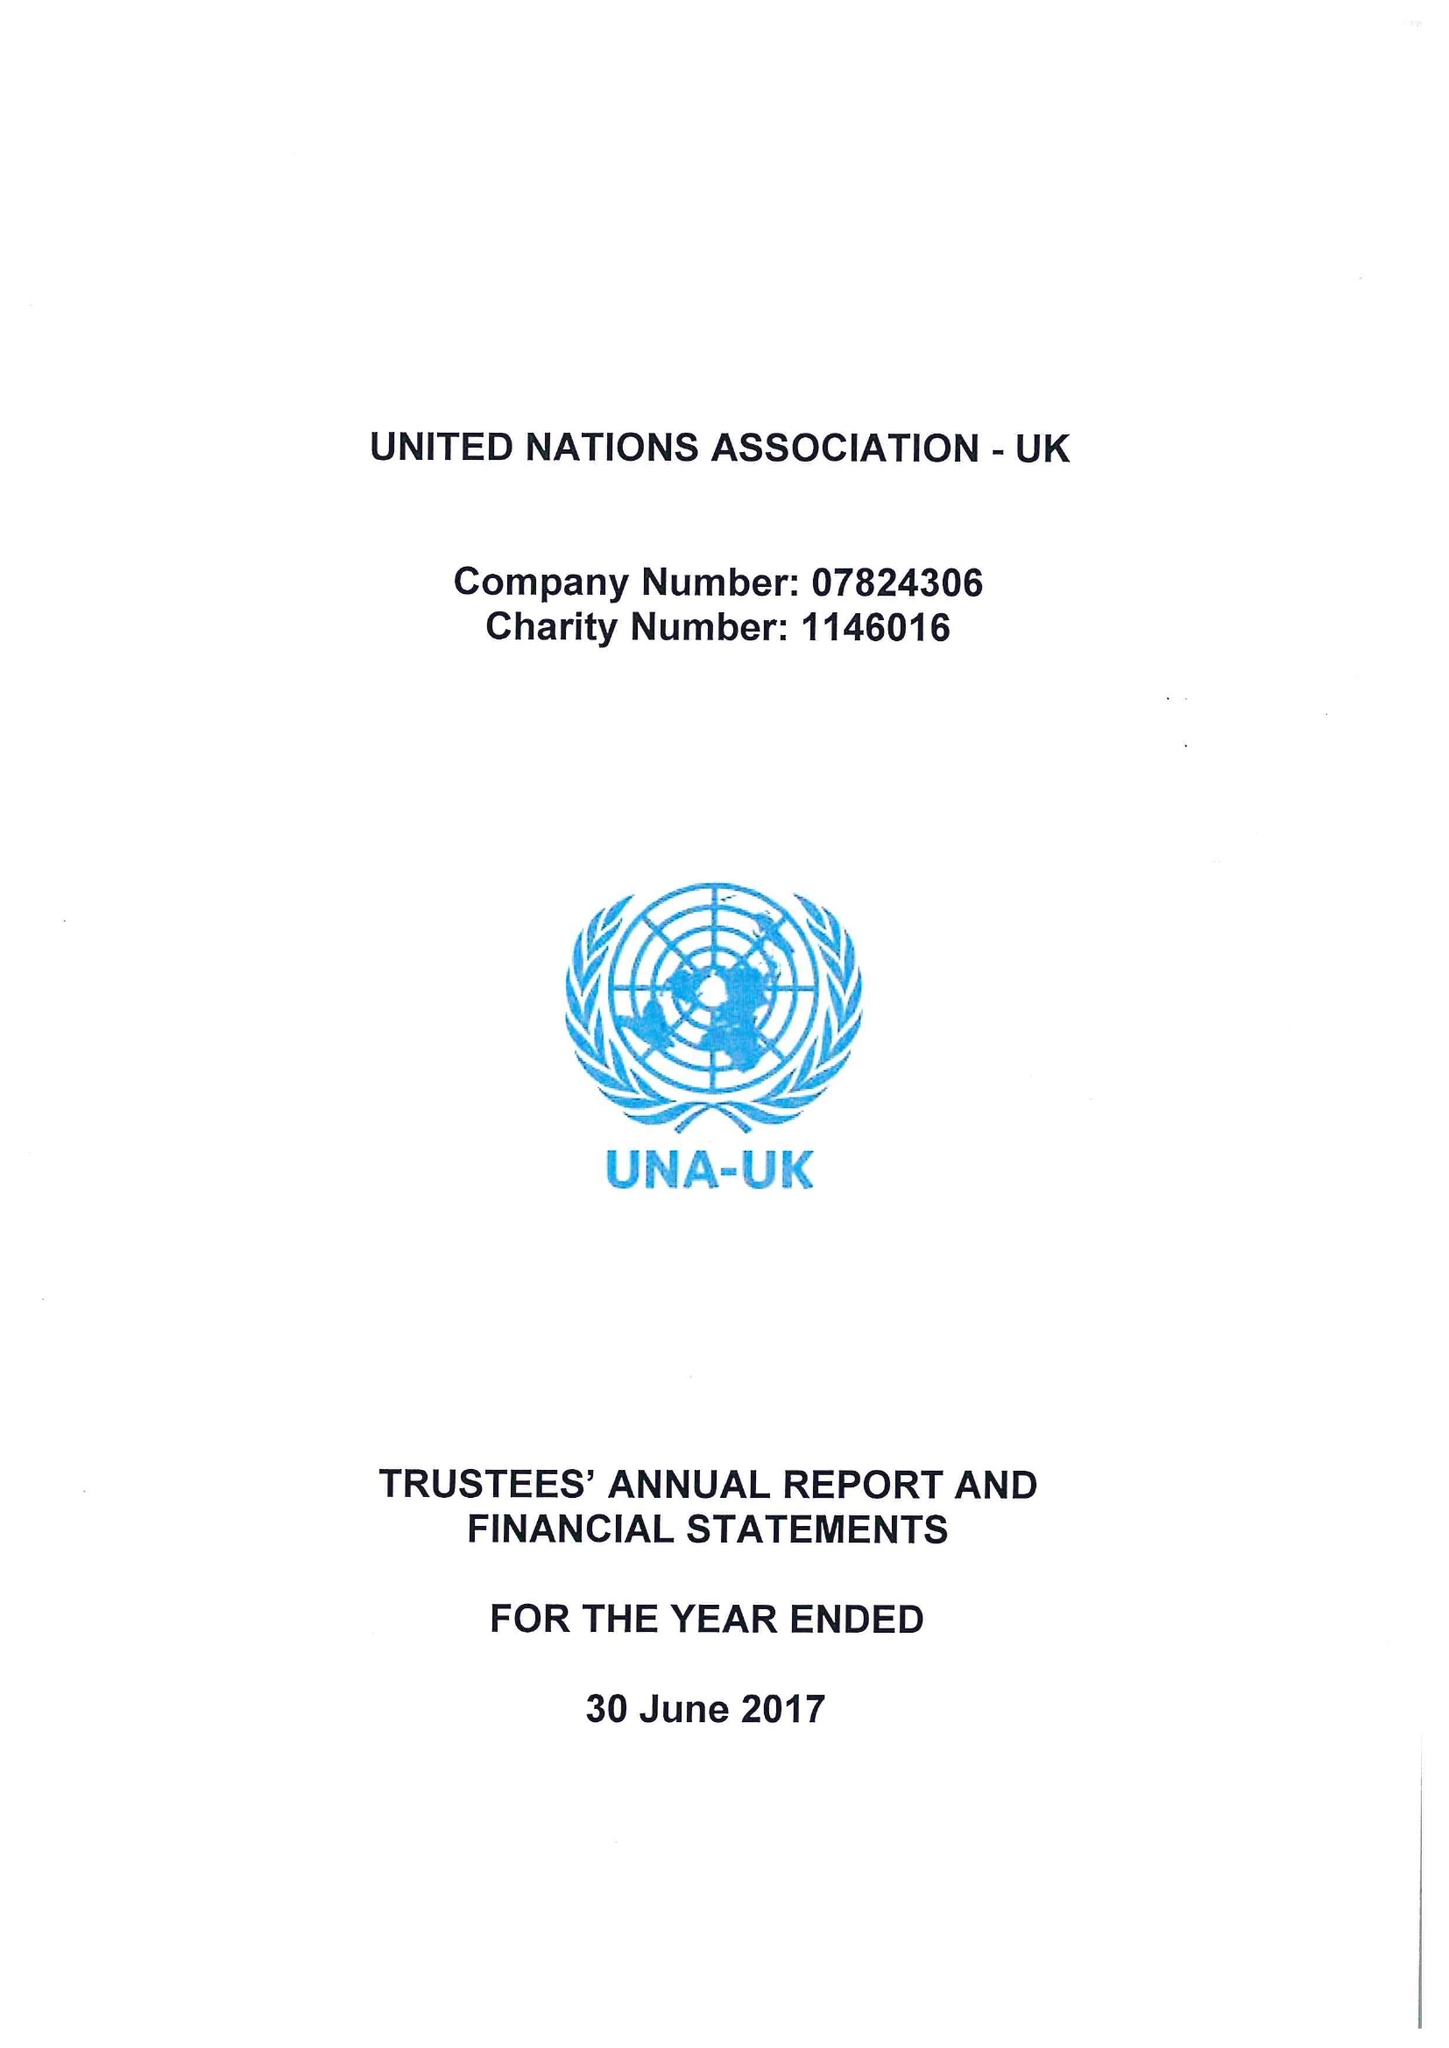What is the value for the report_date?
Answer the question using a single word or phrase. 2017-06-30 